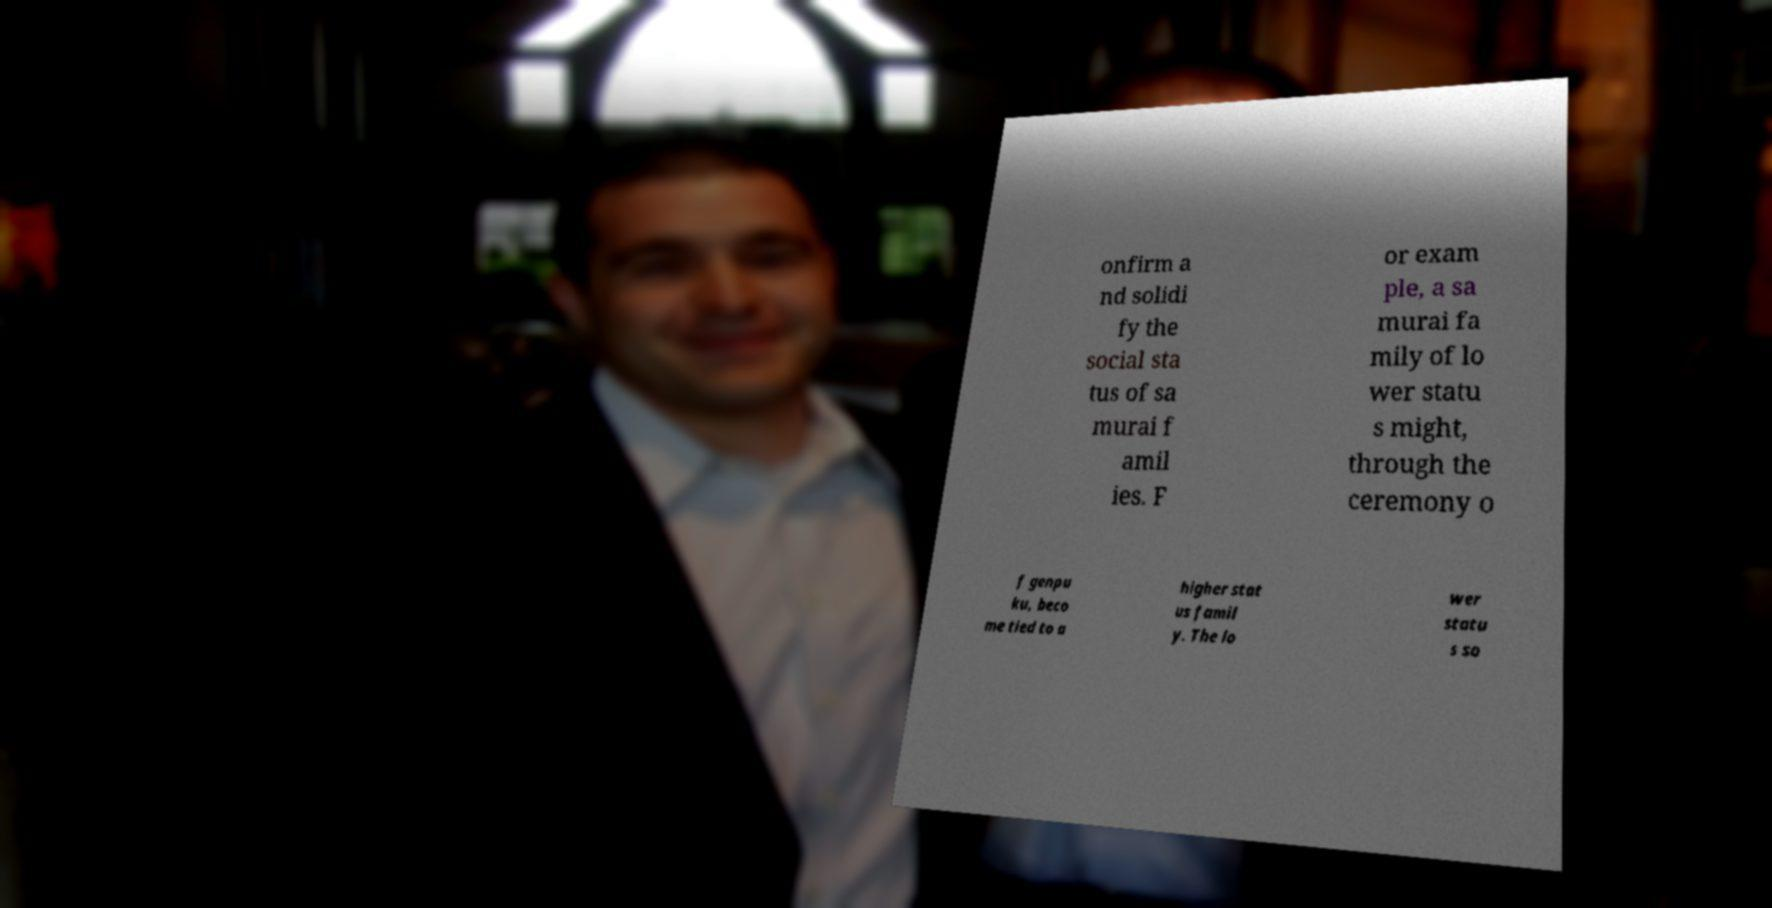For documentation purposes, I need the text within this image transcribed. Could you provide that? onfirm a nd solidi fy the social sta tus of sa murai f amil ies. F or exam ple, a sa murai fa mily of lo wer statu s might, through the ceremony o f genpu ku, beco me tied to a higher stat us famil y. The lo wer statu s so 